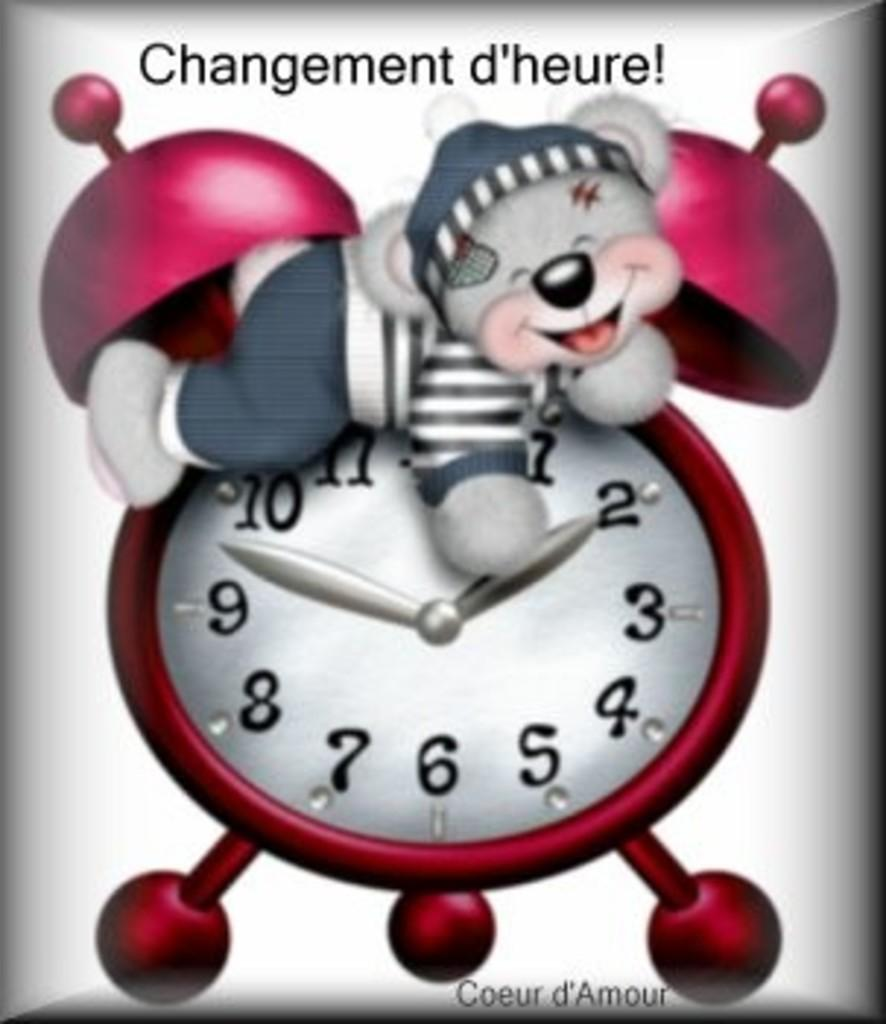<image>
Give a short and clear explanation of the subsequent image. An advertisement for a bear clock that says changement d'heure. 